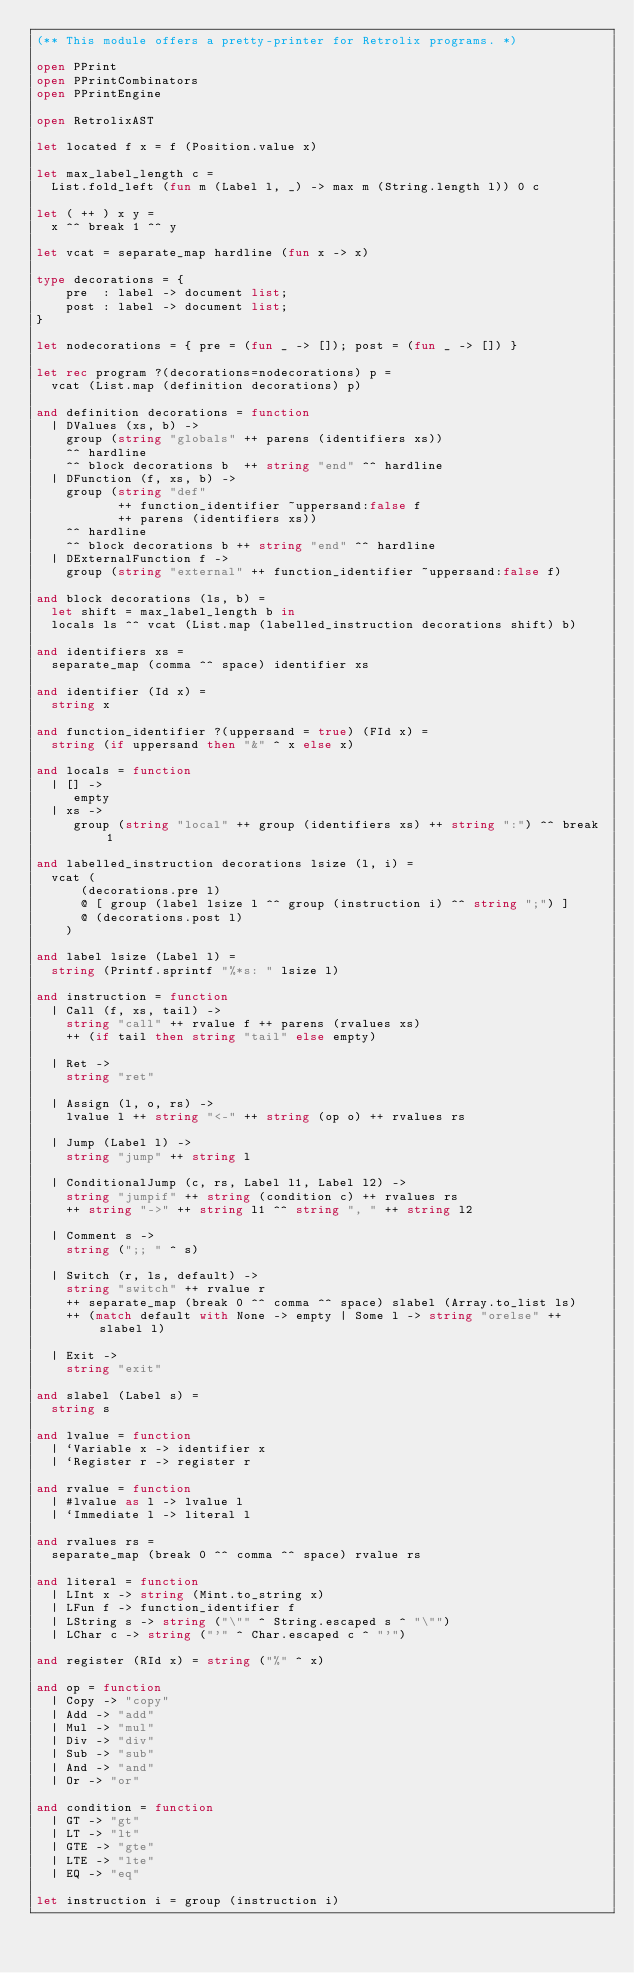Convert code to text. <code><loc_0><loc_0><loc_500><loc_500><_OCaml_>(** This module offers a pretty-printer for Retrolix programs. *)

open PPrint
open PPrintCombinators
open PPrintEngine

open RetrolixAST

let located f x = f (Position.value x)

let max_label_length c =
  List.fold_left (fun m (Label l, _) -> max m (String.length l)) 0 c

let ( ++ ) x y =
  x ^^ break 1 ^^ y

let vcat = separate_map hardline (fun x -> x)

type decorations = {
    pre  : label -> document list;
    post : label -> document list;
}

let nodecorations = { pre = (fun _ -> []); post = (fun _ -> []) }

let rec program ?(decorations=nodecorations) p =
  vcat (List.map (definition decorations) p)

and definition decorations = function
  | DValues (xs, b) ->
    group (string "globals" ++ parens (identifiers xs))
    ^^ hardline
    ^^ block decorations b  ++ string "end" ^^ hardline
  | DFunction (f, xs, b) ->
    group (string "def"
           ++ function_identifier ~uppersand:false f
           ++ parens (identifiers xs))
    ^^ hardline
    ^^ block decorations b ++ string "end" ^^ hardline
  | DExternalFunction f ->
    group (string "external" ++ function_identifier ~uppersand:false f)

and block decorations (ls, b) =
  let shift = max_label_length b in
  locals ls ^^ vcat (List.map (labelled_instruction decorations shift) b)

and identifiers xs =
  separate_map (comma ^^ space) identifier xs

and identifier (Id x) =
  string x

and function_identifier ?(uppersand = true) (FId x) =
  string (if uppersand then "&" ^ x else x)

and locals = function
  | [] ->
     empty
  | xs ->
     group (string "local" ++ group (identifiers xs) ++ string ":") ^^ break 1

and labelled_instruction decorations lsize (l, i) =
  vcat (
      (decorations.pre l)
      @ [ group (label lsize l ^^ group (instruction i) ^^ string ";") ]
      @ (decorations.post l)
    )

and label lsize (Label l) =
  string (Printf.sprintf "%*s: " lsize l)

and instruction = function
  | Call (f, xs, tail) ->
    string "call" ++ rvalue f ++ parens (rvalues xs)
    ++ (if tail then string "tail" else empty)

  | Ret ->
    string "ret"

  | Assign (l, o, rs) ->
    lvalue l ++ string "<-" ++ string (op o) ++ rvalues rs

  | Jump (Label l) ->
    string "jump" ++ string l

  | ConditionalJump (c, rs, Label l1, Label l2) ->
    string "jumpif" ++ string (condition c) ++ rvalues rs
    ++ string "->" ++ string l1 ^^ string ", " ++ string l2

  | Comment s ->
    string (";; " ^ s)

  | Switch (r, ls, default) ->
    string "switch" ++ rvalue r
    ++ separate_map (break 0 ^^ comma ^^ space) slabel (Array.to_list ls)
    ++ (match default with None -> empty | Some l -> string "orelse" ++ slabel l)

  | Exit ->
    string "exit"

and slabel (Label s) =
  string s

and lvalue = function
  | `Variable x -> identifier x
  | `Register r -> register r

and rvalue = function
  | #lvalue as l -> lvalue l
  | `Immediate l -> literal l

and rvalues rs =
  separate_map (break 0 ^^ comma ^^ space) rvalue rs

and literal = function
  | LInt x -> string (Mint.to_string x)
  | LFun f -> function_identifier f
  | LString s -> string ("\"" ^ String.escaped s ^ "\"")
  | LChar c -> string ("'" ^ Char.escaped c ^ "'")

and register (RId x) = string ("%" ^ x)

and op = function
  | Copy -> "copy"
  | Add -> "add"
  | Mul -> "mul"
  | Div -> "div"
  | Sub -> "sub"
  | And -> "and"
  | Or -> "or"

and condition = function
  | GT -> "gt"
  | LT -> "lt"
  | GTE -> "gte"
  | LTE -> "lte"
  | EQ -> "eq"

let instruction i = group (instruction i)
</code> 